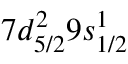Convert formula to latex. <formula><loc_0><loc_0><loc_500><loc_500>7 d _ { 5 / 2 } ^ { 2 } 9 s _ { 1 / 2 } ^ { 1 }</formula> 